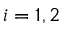<formula> <loc_0><loc_0><loc_500><loc_500>i = 1 , 2</formula> 